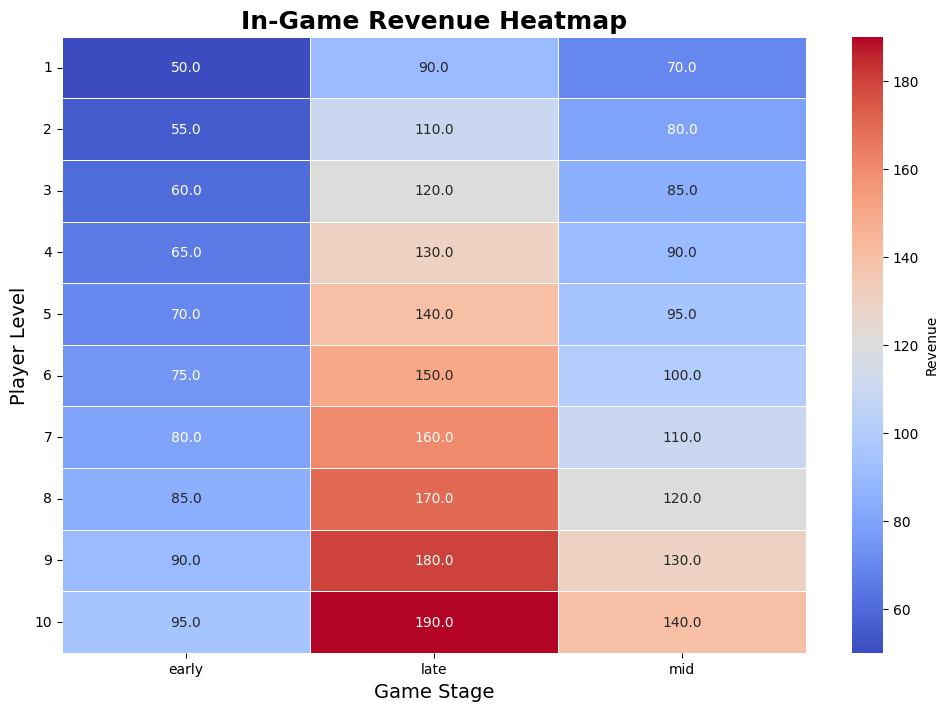What player level generates the highest revenue during the late game stage? Referring to the figure, check the late column and find the highest value. The highest revenue during the late game stage is for player level 10, which is 190.
Answer: 190 What is the difference in revenue between player level 5 and player level 8 during the mid game stage? Check the mid column for both player levels. Player level 5 has a revenue of 95 and player level 8 has a revenue of 120. The difference is 120 - 95 = 25.
Answer: 25 Which game stage has the lowest revenue for player level 3, and what is the revenue value? Look at the row for player level 3 and compare the values in each game stage. The early game stage has the lowest revenue for player level 3, which is 60.
Answer: Early, 60 What's the average revenue for player levels 7 to 9 during the early game stage? Sum the revenues of player levels 7, 8, and 9 during the early game stage: 80 + 85 + 90 = 255. Divide by the number of levels: 255 / 3 = 85.
Answer: 85 Does revenue consistently increase with player level across all game stages? Observe the trend in each game stage column (early, mid, late) to see if the values consistently increase as player level increases from 1 to 10. Each game stage shows increasing revenue with player level, so it is consistent.
Answer: Yes What is the total revenue for player level 6 across all game stages? Add the values for player level 6 across early, mid, and late stages: 75 + 100 + 150 = 325.
Answer: 325 How does the revenue pattern change from the early stage to the late stage? Compare the values in the early column to those in the late column. In general, revenue increases for each player level from early to late stages. For example, player level 1 goes from 50 to 90, and player level 10 goes from 95 to 190.
Answer: Revenue increases Which game stage shows the highest overall revenue, and what is the revenue value? Compare the total revenues for each game stage by summing the values in each column. Late stage has the highest overall revenue: 90+110+120+130+140+150+160+170+180+190 = 1540.
Answer: Late, 1540 